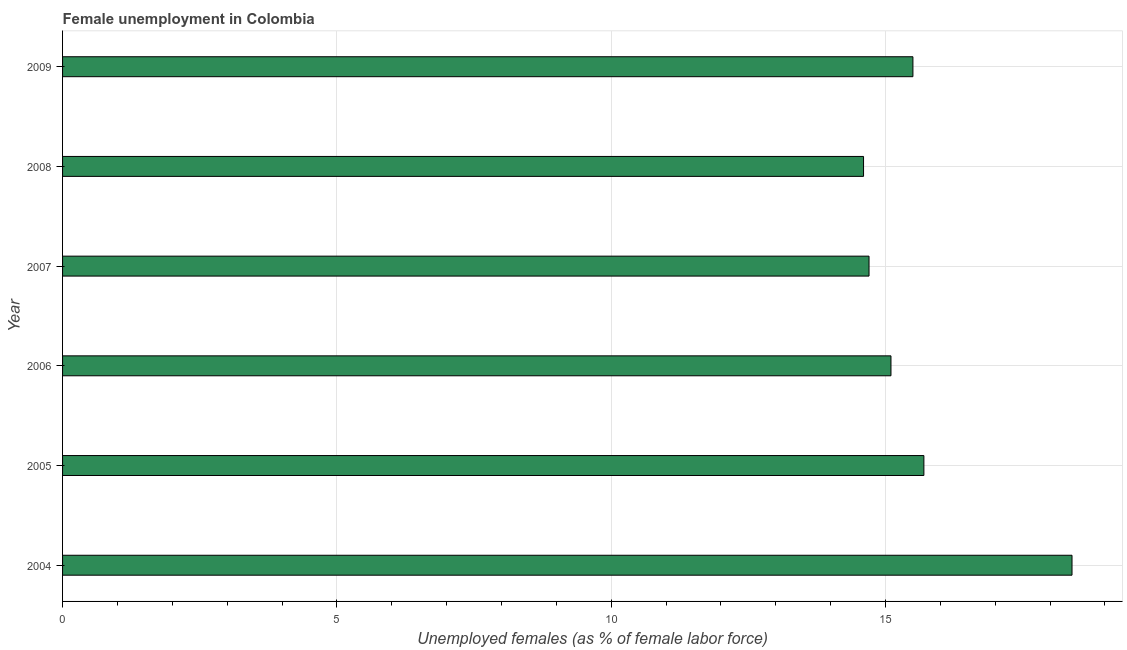Does the graph contain grids?
Your response must be concise. Yes. What is the title of the graph?
Keep it short and to the point. Female unemployment in Colombia. What is the label or title of the X-axis?
Provide a short and direct response. Unemployed females (as % of female labor force). What is the unemployed females population in 2009?
Your answer should be very brief. 15.5. Across all years, what is the maximum unemployed females population?
Ensure brevity in your answer.  18.4. Across all years, what is the minimum unemployed females population?
Ensure brevity in your answer.  14.6. In which year was the unemployed females population maximum?
Make the answer very short. 2004. What is the sum of the unemployed females population?
Give a very brief answer. 94. What is the average unemployed females population per year?
Your answer should be compact. 15.67. What is the median unemployed females population?
Your answer should be compact. 15.3. Do a majority of the years between 2008 and 2005 (inclusive) have unemployed females population greater than 9 %?
Provide a short and direct response. Yes. What is the ratio of the unemployed females population in 2008 to that in 2009?
Your response must be concise. 0.94. Is the unemployed females population in 2006 less than that in 2009?
Your answer should be very brief. Yes. Is the sum of the unemployed females population in 2007 and 2008 greater than the maximum unemployed females population across all years?
Provide a short and direct response. Yes. What is the difference between the highest and the lowest unemployed females population?
Your answer should be very brief. 3.8. Are all the bars in the graph horizontal?
Your response must be concise. Yes. What is the difference between two consecutive major ticks on the X-axis?
Your answer should be compact. 5. What is the Unemployed females (as % of female labor force) of 2004?
Offer a terse response. 18.4. What is the Unemployed females (as % of female labor force) of 2005?
Your answer should be very brief. 15.7. What is the Unemployed females (as % of female labor force) of 2006?
Offer a terse response. 15.1. What is the Unemployed females (as % of female labor force) of 2007?
Provide a succinct answer. 14.7. What is the Unemployed females (as % of female labor force) of 2008?
Your response must be concise. 14.6. What is the Unemployed females (as % of female labor force) in 2009?
Offer a very short reply. 15.5. What is the difference between the Unemployed females (as % of female labor force) in 2004 and 2009?
Ensure brevity in your answer.  2.9. What is the difference between the Unemployed females (as % of female labor force) in 2005 and 2007?
Provide a short and direct response. 1. What is the difference between the Unemployed females (as % of female labor force) in 2006 and 2007?
Provide a succinct answer. 0.4. What is the difference between the Unemployed females (as % of female labor force) in 2006 and 2008?
Your answer should be compact. 0.5. What is the difference between the Unemployed females (as % of female labor force) in 2007 and 2009?
Keep it short and to the point. -0.8. What is the difference between the Unemployed females (as % of female labor force) in 2008 and 2009?
Keep it short and to the point. -0.9. What is the ratio of the Unemployed females (as % of female labor force) in 2004 to that in 2005?
Provide a succinct answer. 1.17. What is the ratio of the Unemployed females (as % of female labor force) in 2004 to that in 2006?
Offer a terse response. 1.22. What is the ratio of the Unemployed females (as % of female labor force) in 2004 to that in 2007?
Ensure brevity in your answer.  1.25. What is the ratio of the Unemployed females (as % of female labor force) in 2004 to that in 2008?
Provide a short and direct response. 1.26. What is the ratio of the Unemployed females (as % of female labor force) in 2004 to that in 2009?
Ensure brevity in your answer.  1.19. What is the ratio of the Unemployed females (as % of female labor force) in 2005 to that in 2006?
Provide a short and direct response. 1.04. What is the ratio of the Unemployed females (as % of female labor force) in 2005 to that in 2007?
Offer a very short reply. 1.07. What is the ratio of the Unemployed females (as % of female labor force) in 2005 to that in 2008?
Keep it short and to the point. 1.07. What is the ratio of the Unemployed females (as % of female labor force) in 2006 to that in 2007?
Your response must be concise. 1.03. What is the ratio of the Unemployed females (as % of female labor force) in 2006 to that in 2008?
Provide a succinct answer. 1.03. What is the ratio of the Unemployed females (as % of female labor force) in 2007 to that in 2009?
Provide a succinct answer. 0.95. What is the ratio of the Unemployed females (as % of female labor force) in 2008 to that in 2009?
Your answer should be compact. 0.94. 